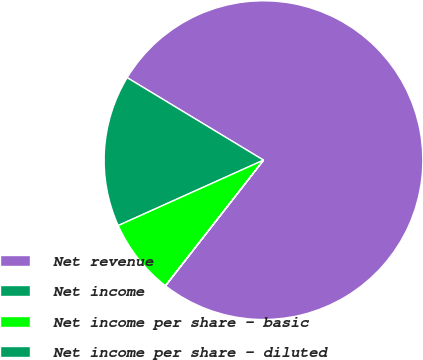Convert chart. <chart><loc_0><loc_0><loc_500><loc_500><pie_chart><fcel>Net revenue<fcel>Net income<fcel>Net income per share - basic<fcel>Net income per share - diluted<nl><fcel>76.87%<fcel>15.39%<fcel>7.71%<fcel>0.02%<nl></chart> 